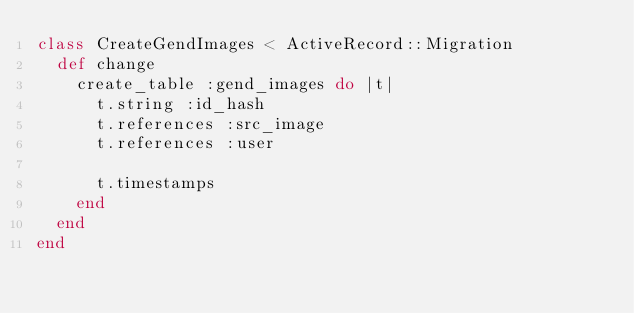Convert code to text. <code><loc_0><loc_0><loc_500><loc_500><_Ruby_>class CreateGendImages < ActiveRecord::Migration
  def change
    create_table :gend_images do |t|
      t.string :id_hash
      t.references :src_image
      t.references :user

      t.timestamps
    end
  end
end
</code> 